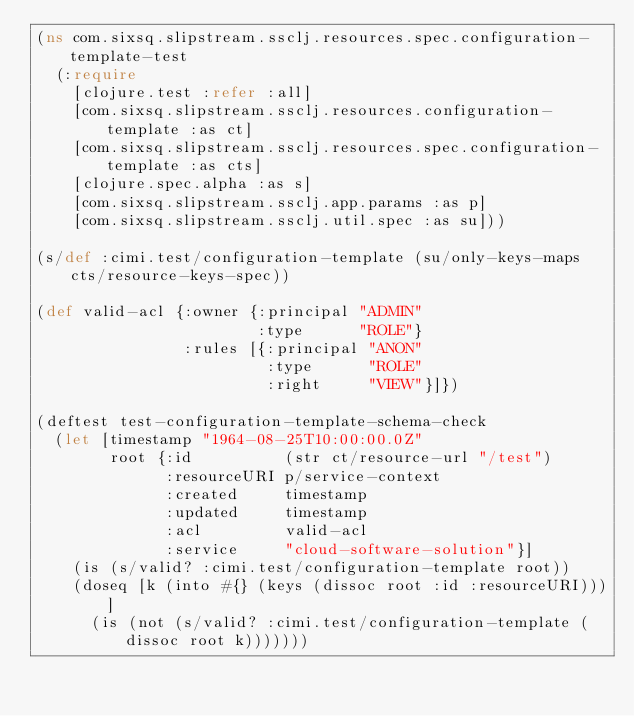Convert code to text. <code><loc_0><loc_0><loc_500><loc_500><_Clojure_>(ns com.sixsq.slipstream.ssclj.resources.spec.configuration-template-test
  (:require
    [clojure.test :refer :all]
    [com.sixsq.slipstream.ssclj.resources.configuration-template :as ct]
    [com.sixsq.slipstream.ssclj.resources.spec.configuration-template :as cts]
    [clojure.spec.alpha :as s]
    [com.sixsq.slipstream.ssclj.app.params :as p]
    [com.sixsq.slipstream.ssclj.util.spec :as su]))

(s/def :cimi.test/configuration-template (su/only-keys-maps cts/resource-keys-spec))

(def valid-acl {:owner {:principal "ADMIN"
                        :type      "ROLE"}
                :rules [{:principal "ANON"
                         :type      "ROLE"
                         :right     "VIEW"}]})

(deftest test-configuration-template-schema-check
  (let [timestamp "1964-08-25T10:00:00.0Z"
        root {:id          (str ct/resource-url "/test")
              :resourceURI p/service-context
              :created     timestamp
              :updated     timestamp
              :acl         valid-acl
              :service     "cloud-software-solution"}]
    (is (s/valid? :cimi.test/configuration-template root))
    (doseq [k (into #{} (keys (dissoc root :id :resourceURI)))]
      (is (not (s/valid? :cimi.test/configuration-template (dissoc root k)))))))
</code> 